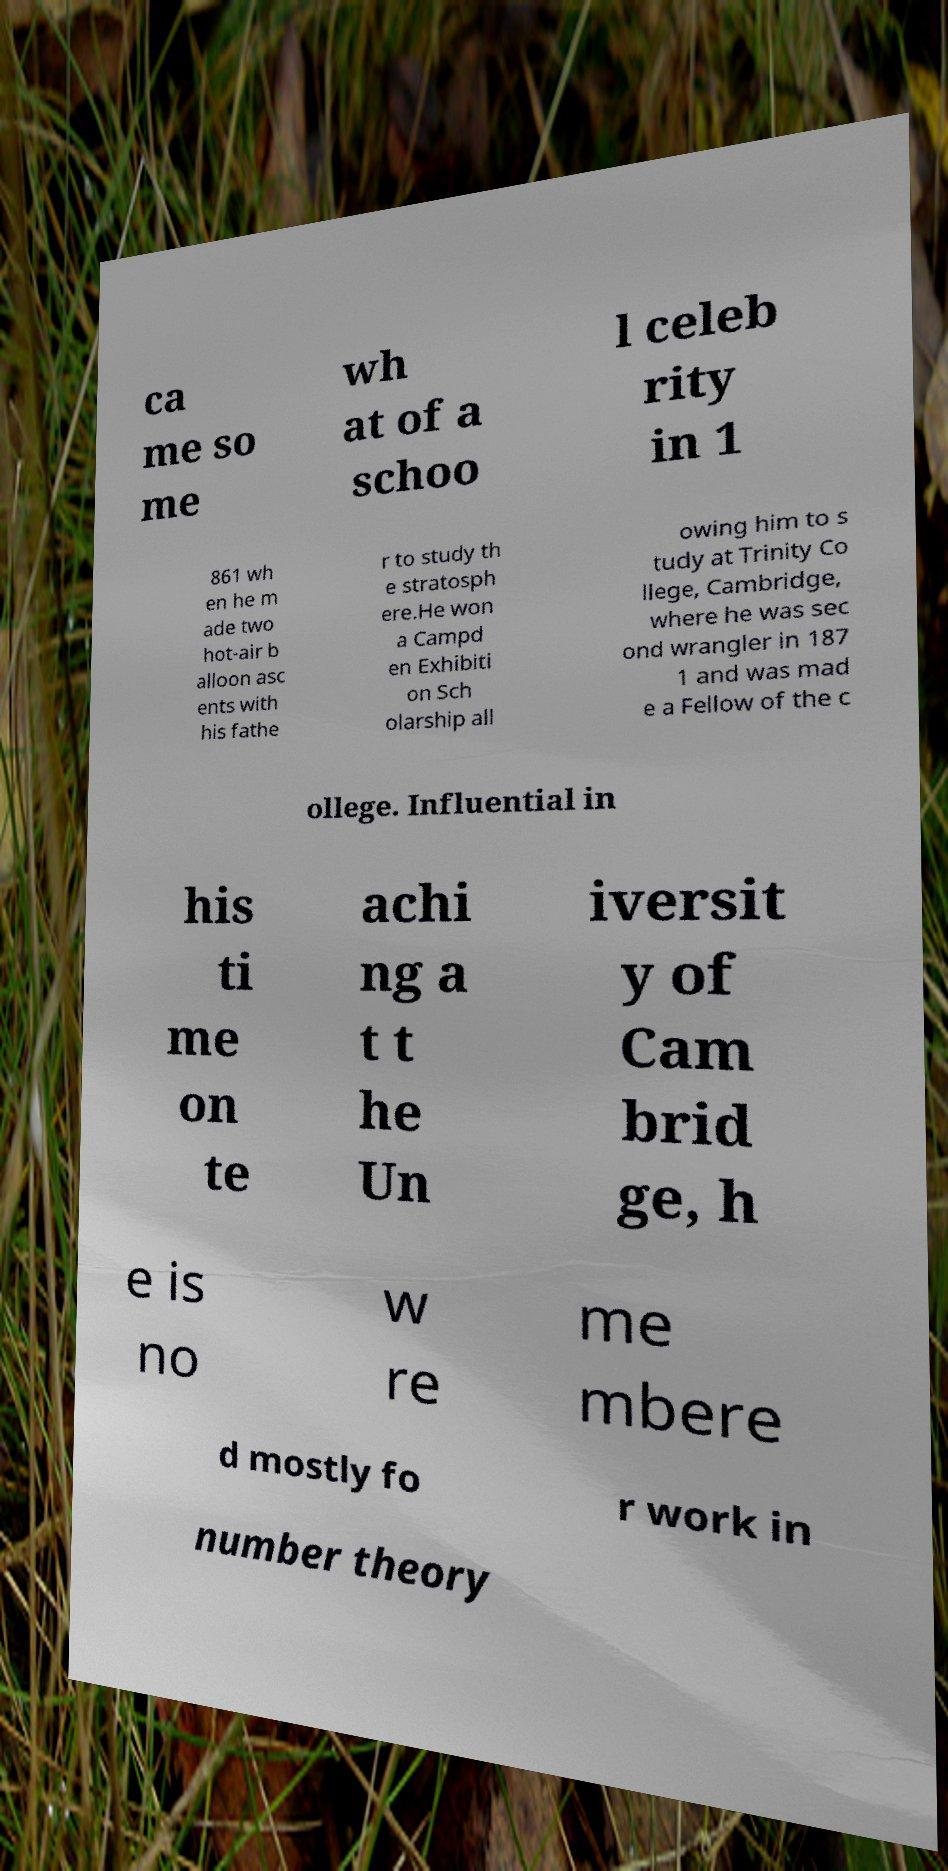Can you read and provide the text displayed in the image?This photo seems to have some interesting text. Can you extract and type it out for me? ca me so me wh at of a schoo l celeb rity in 1 861 wh en he m ade two hot-air b alloon asc ents with his fathe r to study th e stratosph ere.He won a Campd en Exhibiti on Sch olarship all owing him to s tudy at Trinity Co llege, Cambridge, where he was sec ond wrangler in 187 1 and was mad e a Fellow of the c ollege. Influential in his ti me on te achi ng a t t he Un iversit y of Cam brid ge, h e is no w re me mbere d mostly fo r work in number theory 